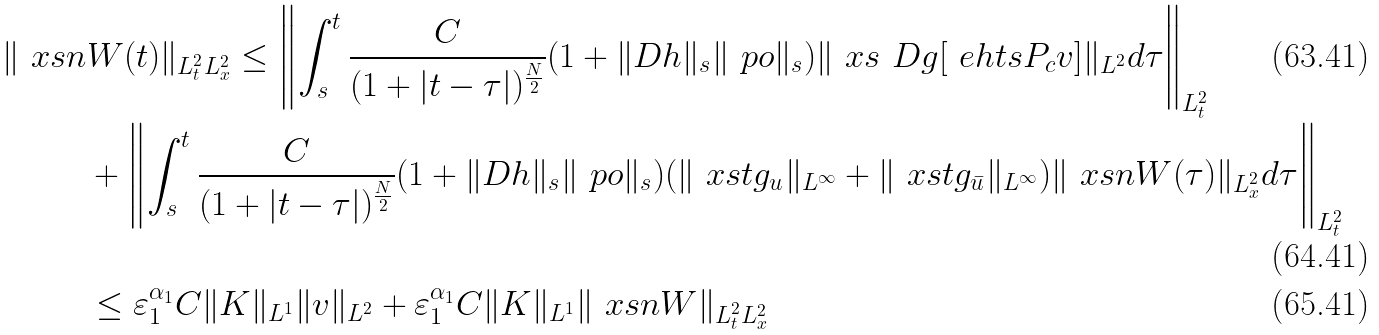Convert formula to latex. <formula><loc_0><loc_0><loc_500><loc_500>\| \ x s n & W ( t ) \| _ { L _ { t } ^ { 2 } L _ { x } ^ { 2 } } \leq \left \| \int _ { s } ^ { t } \frac { C } { ( 1 + | t - \tau | ) ^ { \frac { N } { 2 } } } ( 1 + \| D h \| _ { \L s } \| \ p o \| _ { \L s } ) \| \ x s \ D g [ \ e h t s P _ { c } v ] \| _ { L ^ { 2 } } d \tau \right \| _ { L ^ { 2 } _ { t } } \\ & + \left \| \int _ { s } ^ { t } \frac { C } { ( 1 + | t - \tau | ) ^ { \frac { N } { 2 } } } ( 1 + \| D h \| _ { \L s } \| \ p o \| _ { \L s } ) ( \| \ x s t g _ { u } \| _ { L ^ { \infty } } + \| \ x s t g _ { \bar { u } } \| _ { L ^ { \infty } } ) \| \ x s n W ( \tau ) \| _ { L ^ { 2 } _ { x } } d \tau \right \| _ { L ^ { 2 } _ { t } } \\ & \leq \varepsilon _ { 1 } ^ { \alpha _ { 1 } } C \| K \| _ { L ^ { 1 } } \| v \| _ { L ^ { 2 } } + \varepsilon _ { 1 } ^ { \alpha _ { 1 } } C \| K \| _ { L ^ { 1 } } \| \ x s n W \| _ { L ^ { 2 } _ { t } L ^ { 2 } _ { x } }</formula> 